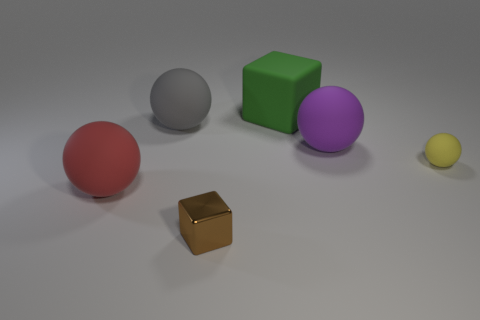Add 1 red shiny cubes. How many objects exist? 7 Subtract all balls. How many objects are left? 2 Subtract all purple rubber objects. Subtract all brown blocks. How many objects are left? 4 Add 3 large rubber objects. How many large rubber objects are left? 7 Add 1 big green rubber cubes. How many big green rubber cubes exist? 2 Subtract 0 blue cylinders. How many objects are left? 6 